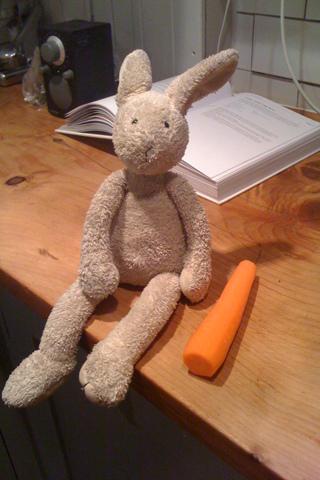Why is it funny that the vegetable is next to the animal?
Concise answer only. Rabbits eat carrots. Can this animal eat the carrot?
Answer briefly. No. What is the plush made of?
Keep it brief. Cotton. 